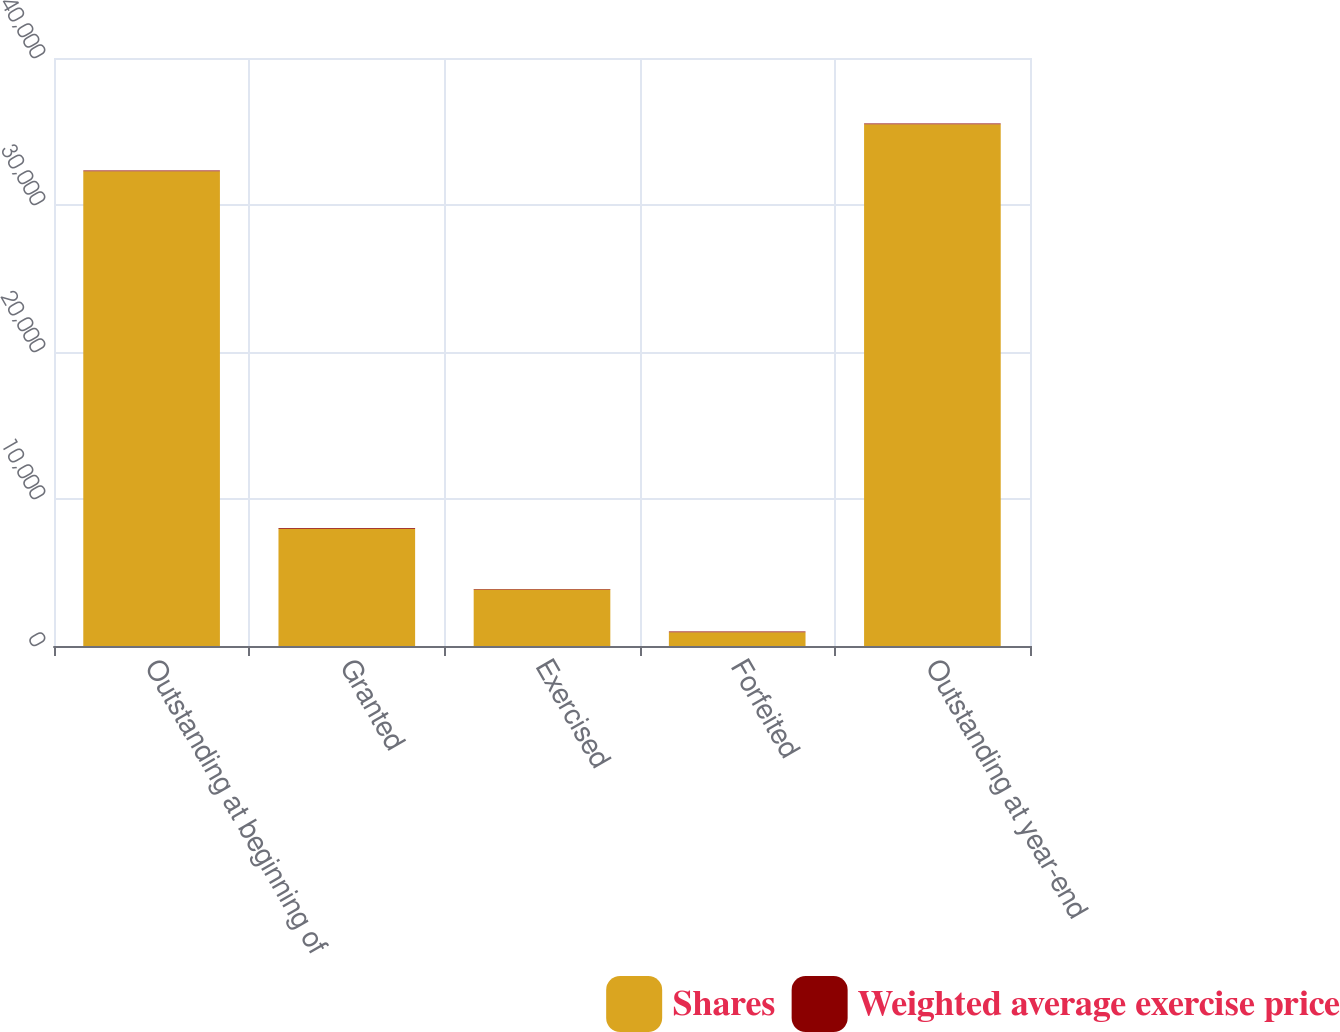Convert chart to OTSL. <chart><loc_0><loc_0><loc_500><loc_500><stacked_bar_chart><ecel><fcel>Outstanding at beginning of<fcel>Granted<fcel>Exercised<fcel>Forfeited<fcel>Outstanding at year-end<nl><fcel>Shares<fcel>32301<fcel>7981<fcel>3851<fcel>931<fcel>35500<nl><fcel>Weighted average exercise price<fcel>50.36<fcel>40.87<fcel>29<fcel>58.82<fcel>50.3<nl></chart> 